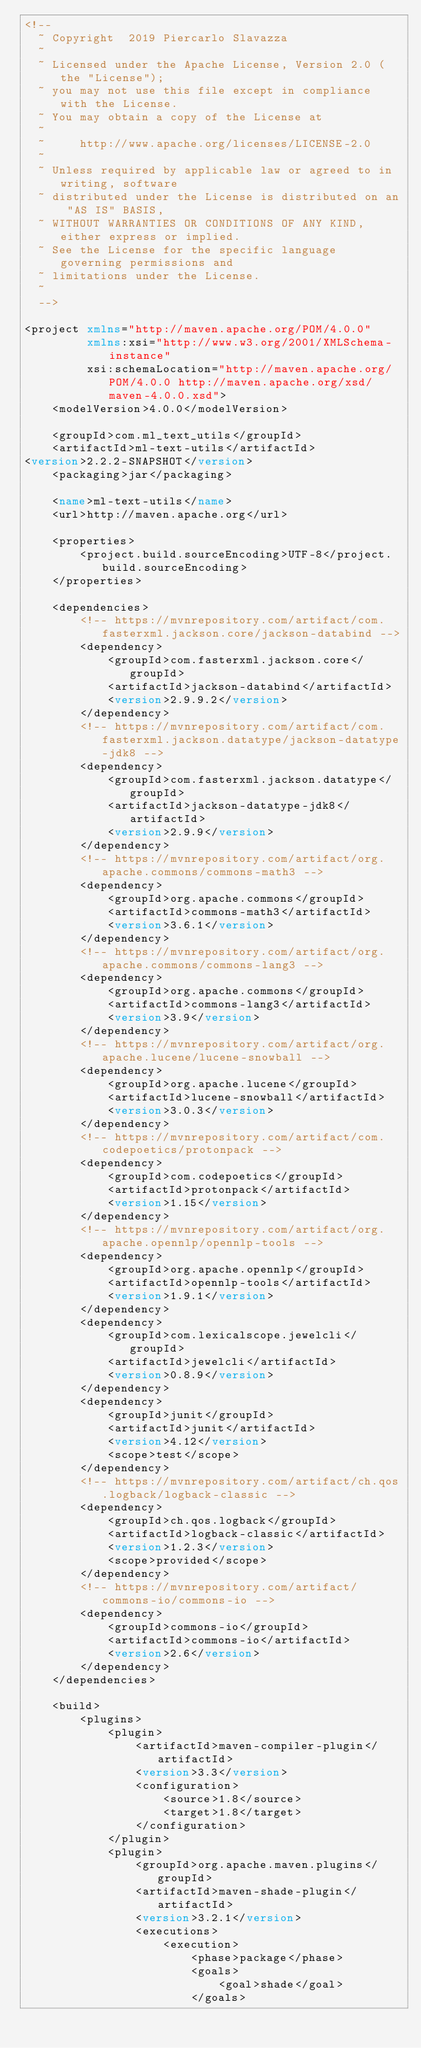<code> <loc_0><loc_0><loc_500><loc_500><_XML_><!--
  ~ Copyright  2019 Piercarlo Slavazza
  ~
  ~ Licensed under the Apache License, Version 2.0 (the "License");
  ~ you may not use this file except in compliance with the License.
  ~ You may obtain a copy of the License at
  ~
  ~     http://www.apache.org/licenses/LICENSE-2.0
  ~
  ~ Unless required by applicable law or agreed to in writing, software
  ~ distributed under the License is distributed on an "AS IS" BASIS,
  ~ WITHOUT WARRANTIES OR CONDITIONS OF ANY KIND, either express or implied.
  ~ See the License for the specific language governing permissions and
  ~ limitations under the License.
  ~
  -->

<project xmlns="http://maven.apache.org/POM/4.0.0"
         xmlns:xsi="http://www.w3.org/2001/XMLSchema-instance"
         xsi:schemaLocation="http://maven.apache.org/POM/4.0.0 http://maven.apache.org/xsd/maven-4.0.0.xsd">
    <modelVersion>4.0.0</modelVersion>

    <groupId>com.ml_text_utils</groupId>
    <artifactId>ml-text-utils</artifactId>
<version>2.2.2-SNAPSHOT</version>
    <packaging>jar</packaging>

    <name>ml-text-utils</name>
    <url>http://maven.apache.org</url>

    <properties>
        <project.build.sourceEncoding>UTF-8</project.build.sourceEncoding>
    </properties>

    <dependencies>
        <!-- https://mvnrepository.com/artifact/com.fasterxml.jackson.core/jackson-databind -->
        <dependency>
            <groupId>com.fasterxml.jackson.core</groupId>
            <artifactId>jackson-databind</artifactId>
            <version>2.9.9.2</version>
        </dependency>
        <!-- https://mvnrepository.com/artifact/com.fasterxml.jackson.datatype/jackson-datatype-jdk8 -->
        <dependency>
            <groupId>com.fasterxml.jackson.datatype</groupId>
            <artifactId>jackson-datatype-jdk8</artifactId>
            <version>2.9.9</version>
        </dependency>
        <!-- https://mvnrepository.com/artifact/org.apache.commons/commons-math3 -->
        <dependency>
            <groupId>org.apache.commons</groupId>
            <artifactId>commons-math3</artifactId>
            <version>3.6.1</version>
        </dependency>
        <!-- https://mvnrepository.com/artifact/org.apache.commons/commons-lang3 -->
        <dependency>
            <groupId>org.apache.commons</groupId>
            <artifactId>commons-lang3</artifactId>
            <version>3.9</version>
        </dependency>
        <!-- https://mvnrepository.com/artifact/org.apache.lucene/lucene-snowball -->
        <dependency>
            <groupId>org.apache.lucene</groupId>
            <artifactId>lucene-snowball</artifactId>
            <version>3.0.3</version>
        </dependency>
        <!-- https://mvnrepository.com/artifact/com.codepoetics/protonpack -->
        <dependency>
            <groupId>com.codepoetics</groupId>
            <artifactId>protonpack</artifactId>
            <version>1.15</version>
        </dependency>
        <!-- https://mvnrepository.com/artifact/org.apache.opennlp/opennlp-tools -->
        <dependency>
            <groupId>org.apache.opennlp</groupId>
            <artifactId>opennlp-tools</artifactId>
            <version>1.9.1</version>
        </dependency>
        <dependency>
            <groupId>com.lexicalscope.jewelcli</groupId>
            <artifactId>jewelcli</artifactId>
            <version>0.8.9</version>
        </dependency>
        <dependency>
            <groupId>junit</groupId>
            <artifactId>junit</artifactId>
            <version>4.12</version>
            <scope>test</scope>
        </dependency>
        <!-- https://mvnrepository.com/artifact/ch.qos.logback/logback-classic -->
        <dependency>
            <groupId>ch.qos.logback</groupId>
            <artifactId>logback-classic</artifactId>
            <version>1.2.3</version>
            <scope>provided</scope>
        </dependency>
        <!-- https://mvnrepository.com/artifact/commons-io/commons-io -->
        <dependency>
            <groupId>commons-io</groupId>
            <artifactId>commons-io</artifactId>
            <version>2.6</version>
        </dependency>
    </dependencies>

    <build>
        <plugins>
            <plugin>
                <artifactId>maven-compiler-plugin</artifactId>
                <version>3.3</version>
                <configuration>
                    <source>1.8</source>
                    <target>1.8</target>
                </configuration>
            </plugin>
            <plugin>
                <groupId>org.apache.maven.plugins</groupId>
                <artifactId>maven-shade-plugin</artifactId>
                <version>3.2.1</version>
                <executions>
                    <execution>
                        <phase>package</phase>
                        <goals>
                            <goal>shade</goal>
                        </goals></code> 